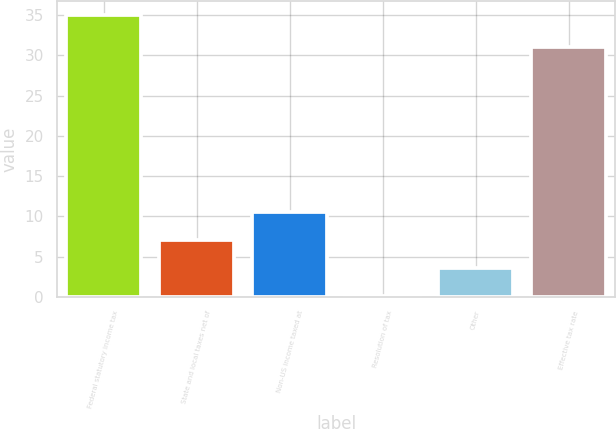Convert chart to OTSL. <chart><loc_0><loc_0><loc_500><loc_500><bar_chart><fcel>Federal statutory income tax<fcel>State and local taxes net of<fcel>Non-US income taxed at<fcel>Resolution of tax<fcel>Other<fcel>Effective tax rate<nl><fcel>35<fcel>7.08<fcel>10.57<fcel>0.1<fcel>3.59<fcel>31<nl></chart> 